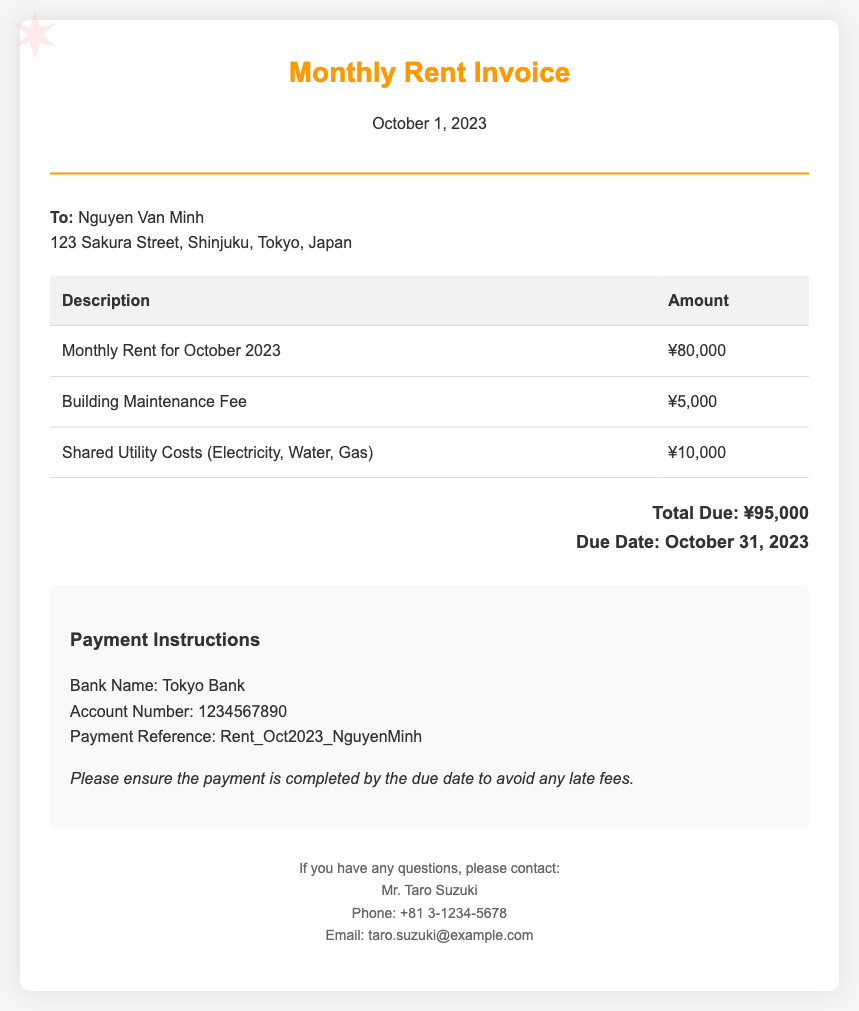what is the total due amount? The total due amount is the sum of monthly rent, maintenance fee, and shared utility costs, which is ¥80,000 + ¥5,000 + ¥10,000.
Answer: ¥95,000 when is the due date? The document specifies the due date for the payment of the invoice.
Answer: October 31, 2023 who is the recipient of the invoice? The name and address of the recipient are provided in the document.
Answer: Nguyen Van Minh what is the building maintenance fee? The invoice lists the amount specified for building maintenance.
Answer: ¥5,000 what bank should the payment be made to? The document contains the bank name where the payment is to be made.
Answer: Tokyo Bank what is the payment reference needed? The document includes a specific payment reference for the transaction.
Answer: Rent_Oct2023_NguyenMinh how much are the shared utility costs? The document details the amount charged for shared utilities.
Answer: ¥10,000 who should be contacted for questions? The contact person for any inquiries is specified in the document.
Answer: Mr. Taro Suzuki what is the monthly rent for October 2023? The invoice includes the monthly rent amount for the specified month.
Answer: ¥80,000 